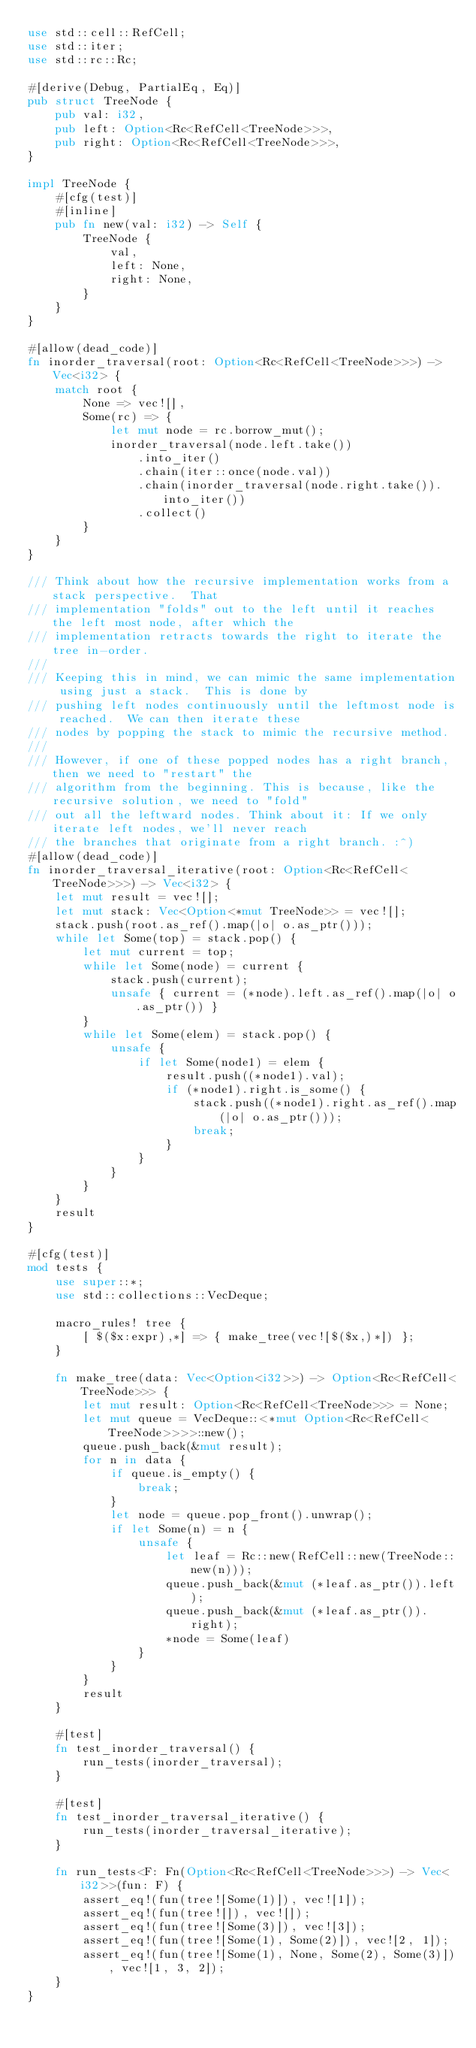<code> <loc_0><loc_0><loc_500><loc_500><_Rust_>use std::cell::RefCell;
use std::iter;
use std::rc::Rc;

#[derive(Debug, PartialEq, Eq)]
pub struct TreeNode {
    pub val: i32,
    pub left: Option<Rc<RefCell<TreeNode>>>,
    pub right: Option<Rc<RefCell<TreeNode>>>,
}

impl TreeNode {
    #[cfg(test)]
    #[inline]
    pub fn new(val: i32) -> Self {
        TreeNode {
            val,
            left: None,
            right: None,
        }
    }
}

#[allow(dead_code)]
fn inorder_traversal(root: Option<Rc<RefCell<TreeNode>>>) -> Vec<i32> {
    match root {
        None => vec![],
        Some(rc) => {
            let mut node = rc.borrow_mut();
            inorder_traversal(node.left.take())
                .into_iter()
                .chain(iter::once(node.val))
                .chain(inorder_traversal(node.right.take()).into_iter())
                .collect()
        }
    }
}

/// Think about how the recursive implementation works from a stack perspective.  That
/// implementation "folds" out to the left until it reaches the left most node, after which the
/// implementation retracts towards the right to iterate the tree in-order.
///
/// Keeping this in mind, we can mimic the same implementation using just a stack.  This is done by
/// pushing left nodes continuously until the leftmost node is reached.  We can then iterate these
/// nodes by popping the stack to mimic the recursive method.
///
/// However, if one of these popped nodes has a right branch, then we need to "restart" the
/// algorithm from the beginning. This is because, like the recursive solution, we need to "fold"
/// out all the leftward nodes. Think about it: If we only iterate left nodes, we'll never reach
/// the branches that originate from a right branch. :^)
#[allow(dead_code)]
fn inorder_traversal_iterative(root: Option<Rc<RefCell<TreeNode>>>) -> Vec<i32> {
    let mut result = vec![];
    let mut stack: Vec<Option<*mut TreeNode>> = vec![];
    stack.push(root.as_ref().map(|o| o.as_ptr()));
    while let Some(top) = stack.pop() {
        let mut current = top;
        while let Some(node) = current {
            stack.push(current);
            unsafe { current = (*node).left.as_ref().map(|o| o.as_ptr()) }
        }
        while let Some(elem) = stack.pop() {
            unsafe {
                if let Some(node1) = elem {
                    result.push((*node1).val);
                    if (*node1).right.is_some() {
                        stack.push((*node1).right.as_ref().map(|o| o.as_ptr()));
                        break;
                    }
                }
            }
        }
    }
    result
}

#[cfg(test)]
mod tests {
    use super::*;
    use std::collections::VecDeque;

    macro_rules! tree {
        [ $($x:expr),*] => { make_tree(vec![$($x,)*]) };
    }

    fn make_tree(data: Vec<Option<i32>>) -> Option<Rc<RefCell<TreeNode>>> {
        let mut result: Option<Rc<RefCell<TreeNode>>> = None;
        let mut queue = VecDeque::<*mut Option<Rc<RefCell<TreeNode>>>>::new();
        queue.push_back(&mut result);
        for n in data {
            if queue.is_empty() {
                break;
            }
            let node = queue.pop_front().unwrap();
            if let Some(n) = n {
                unsafe {
                    let leaf = Rc::new(RefCell::new(TreeNode::new(n)));
                    queue.push_back(&mut (*leaf.as_ptr()).left);
                    queue.push_back(&mut (*leaf.as_ptr()).right);
                    *node = Some(leaf)
                }
            }
        }
        result
    }

    #[test]
    fn test_inorder_traversal() {
        run_tests(inorder_traversal);
    }

    #[test]
    fn test_inorder_traversal_iterative() {
        run_tests(inorder_traversal_iterative);
    }

    fn run_tests<F: Fn(Option<Rc<RefCell<TreeNode>>>) -> Vec<i32>>(fun: F) {
        assert_eq!(fun(tree![Some(1)]), vec![1]);
        assert_eq!(fun(tree![]), vec![]);
        assert_eq!(fun(tree![Some(3)]), vec![3]);
        assert_eq!(fun(tree![Some(1), Some(2)]), vec![2, 1]);
        assert_eq!(fun(tree![Some(1), None, Some(2), Some(3)]), vec![1, 3, 2]);
    }
}
</code> 